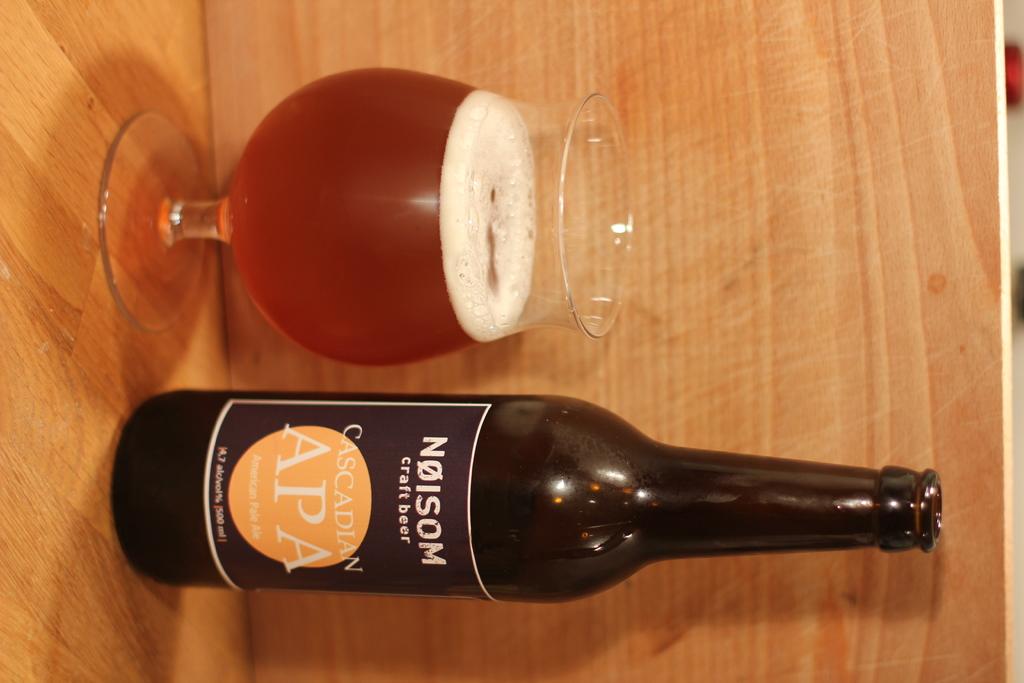What kind of beer is this?
Your answer should be compact. Craft. 